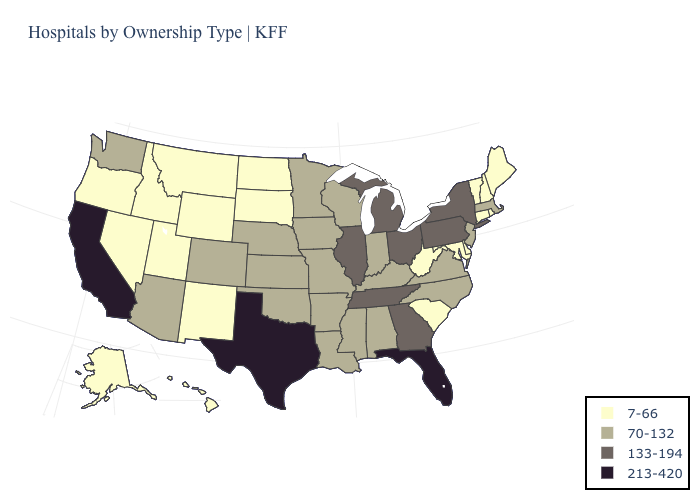What is the highest value in states that border Massachusetts?
Keep it brief. 133-194. What is the value of Ohio?
Be succinct. 133-194. Does Oklahoma have the lowest value in the USA?
Give a very brief answer. No. What is the lowest value in the MidWest?
Write a very short answer. 7-66. What is the highest value in the MidWest ?
Keep it brief. 133-194. Among the states that border Pennsylvania , which have the lowest value?
Write a very short answer. Delaware, Maryland, West Virginia. Name the states that have a value in the range 70-132?
Quick response, please. Alabama, Arizona, Arkansas, Colorado, Indiana, Iowa, Kansas, Kentucky, Louisiana, Massachusetts, Minnesota, Mississippi, Missouri, Nebraska, New Jersey, North Carolina, Oklahoma, Virginia, Washington, Wisconsin. Among the states that border West Virginia , does Ohio have the highest value?
Give a very brief answer. Yes. Does Utah have the highest value in the USA?
Concise answer only. No. Does Texas have the highest value in the USA?
Be succinct. Yes. What is the value of Oregon?
Keep it brief. 7-66. Does Colorado have the lowest value in the West?
Keep it brief. No. Which states have the highest value in the USA?
Answer briefly. California, Florida, Texas. Name the states that have a value in the range 70-132?
Concise answer only. Alabama, Arizona, Arkansas, Colorado, Indiana, Iowa, Kansas, Kentucky, Louisiana, Massachusetts, Minnesota, Mississippi, Missouri, Nebraska, New Jersey, North Carolina, Oklahoma, Virginia, Washington, Wisconsin. Which states hav the highest value in the MidWest?
Be succinct. Illinois, Michigan, Ohio. 